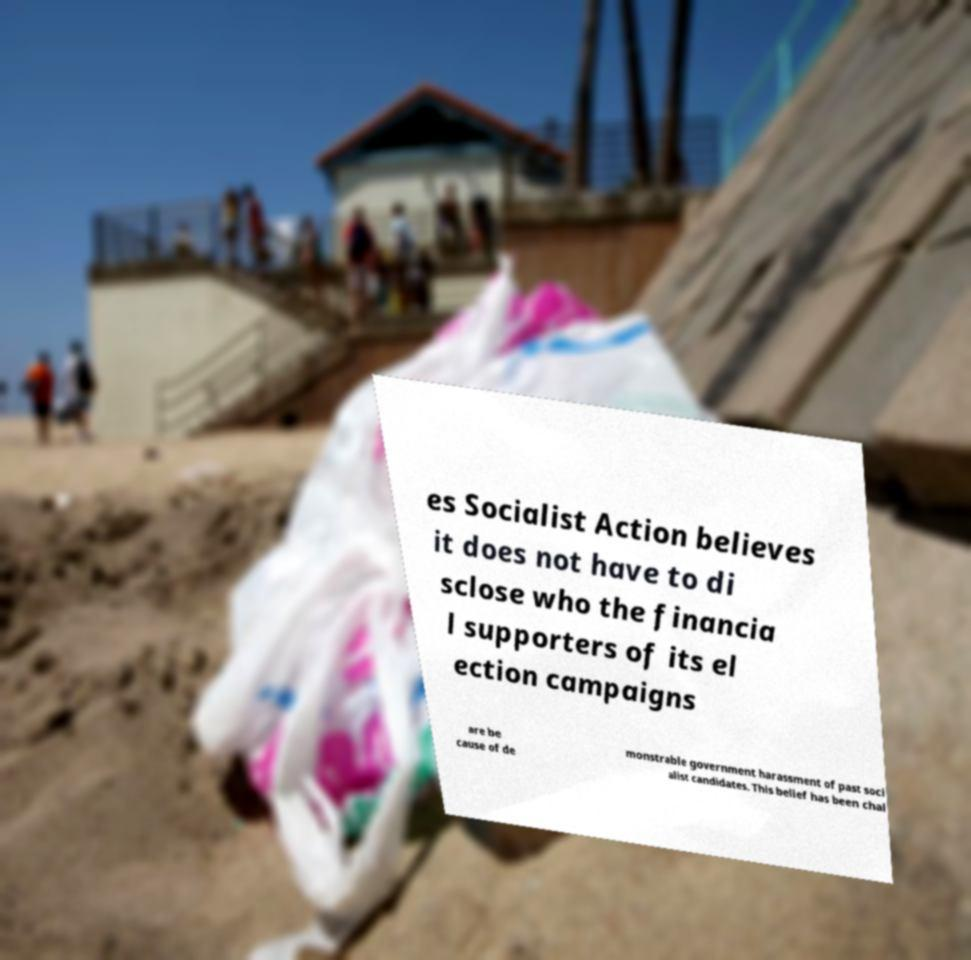Can you read and provide the text displayed in the image?This photo seems to have some interesting text. Can you extract and type it out for me? es Socialist Action believes it does not have to di sclose who the financia l supporters of its el ection campaigns are be cause of de monstrable government harassment of past soci alist candidates. This belief has been chal 